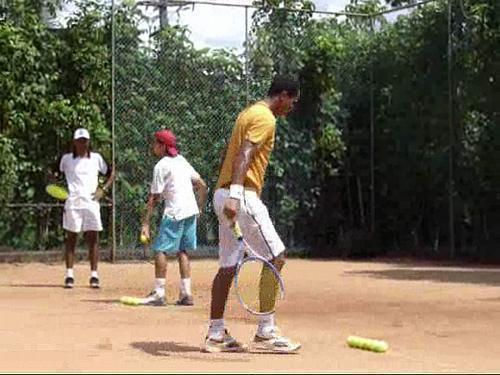What is the man looking down at?
Indicate the correct response by choosing from the four available options to answer the question.
Options: Onions, cue balls, tennis balls, apples. Tennis balls. 